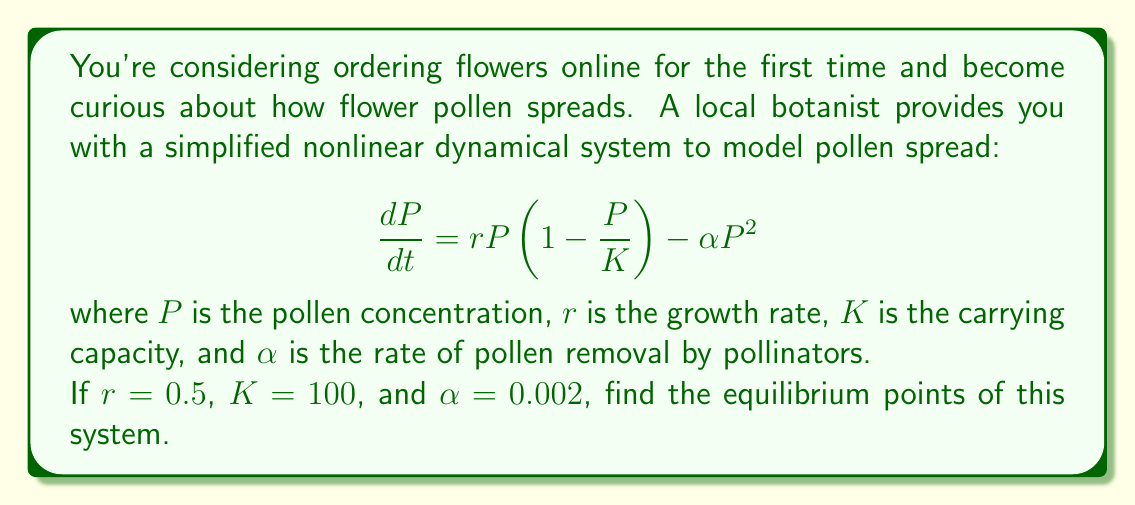Can you answer this question? To find the equilibrium points, we set $\frac{dP}{dt} = 0$ and solve for $P$:

1) Set the equation equal to zero:
   $$0 = rP(1 - \frac{P}{K}) - \alpha P^2$$

2) Substitute the given values:
   $$0 = 0.5P(1 - \frac{P}{100}) - 0.002P^2$$

3) Expand the equation:
   $$0 = 0.5P - 0.005P^2 - 0.002P^2$$
   $$0 = 0.5P - 0.007P^2$$

4) Factor out $P$:
   $$0 = P(0.5 - 0.007P)$$

5) Solve for $P$:
   Either $P = 0$ or $0.5 - 0.007P = 0$

6) For the second case:
   $$0.5 = 0.007P$$
   $$P = \frac{0.5}{0.007} \approx 71.43$$

Therefore, the equilibrium points are $P = 0$ and $P \approx 71.43$.
Answer: $P = 0$ and $P \approx 71.43$ 